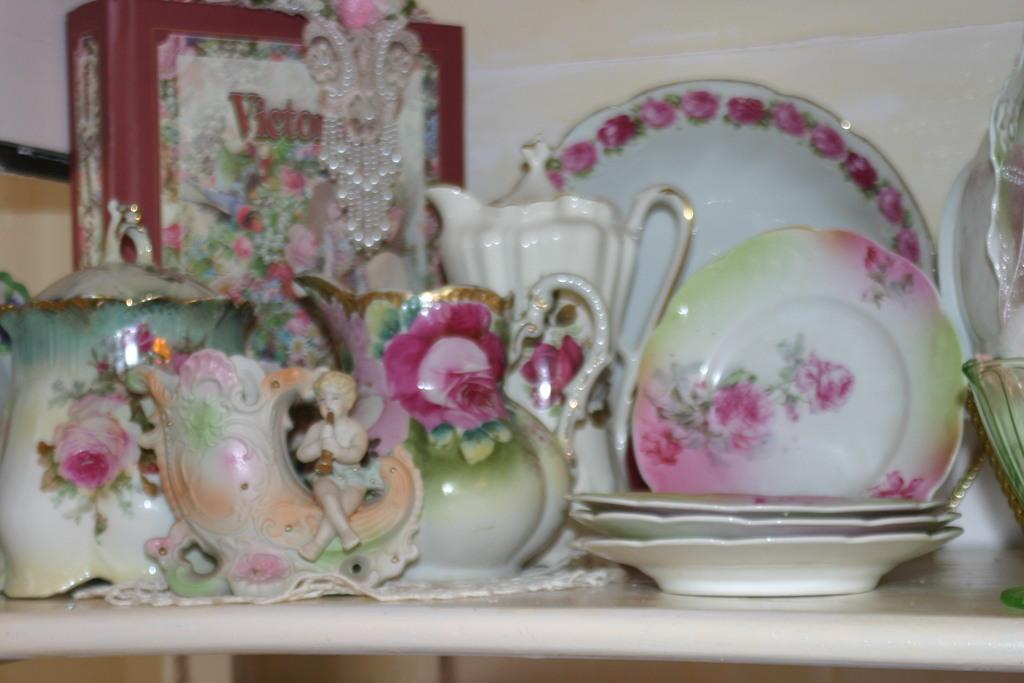What type of kitchenware is visible in the image? There are ceramic kettles, jars, and plates in the image. What is the color of the surface on which the objects are placed? The objects are placed on a white surface. What type of bird can be seen perched on the kettle in the image? There are no birds present in the image, and the kettles are not depicted as having any bird perched on them. 